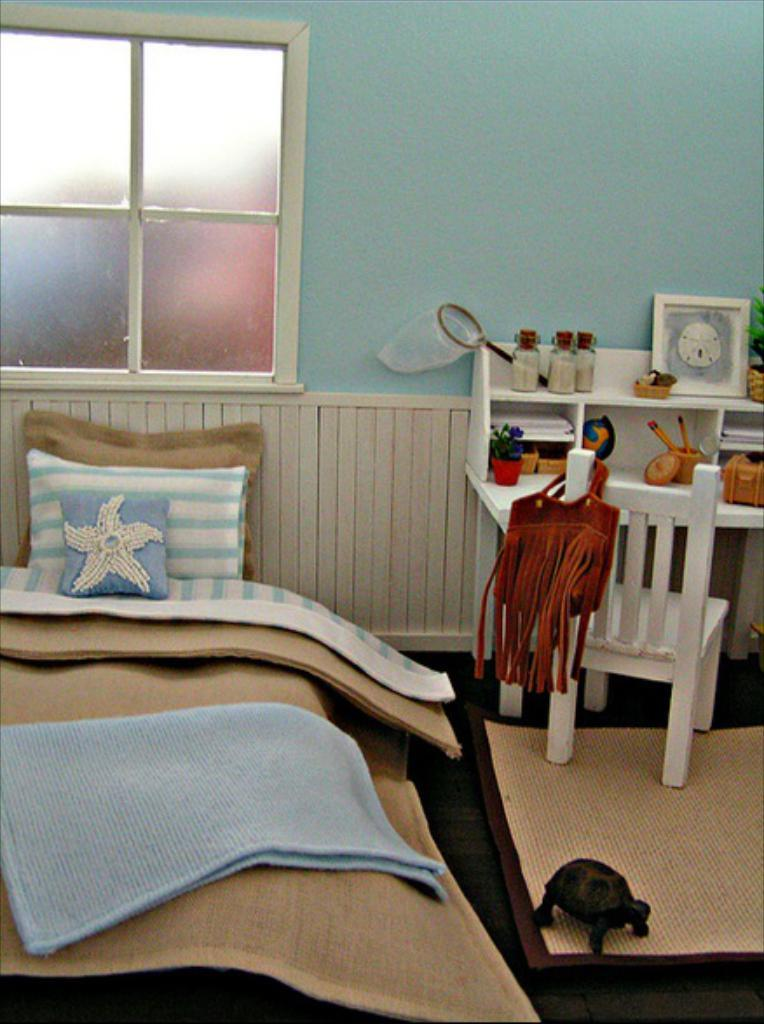What type of furniture is present in the image? There is a bed, a chair, and a desk in the image. What is on the bed in the image? There are cushions on the bed. What is located near the bed in the image? There is a bag in the image. What is on the desk in the image? There are plants, jars, and a frame on the desk. Is there any rain visible in the image? No, there is no rain visible in the image. What type of plant is growing inside the bag in the image? There is no plant growing inside the bag in the image; it is a bag, not a plant container. 